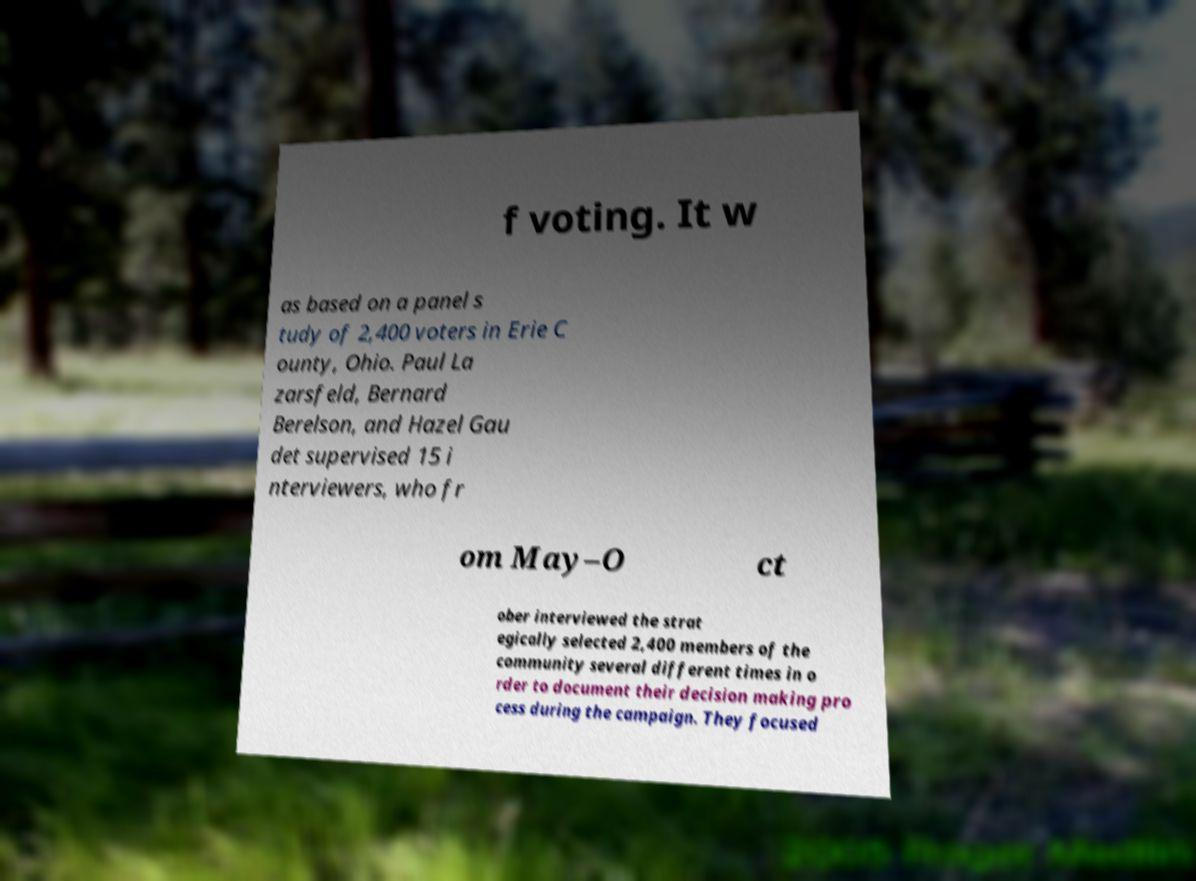There's text embedded in this image that I need extracted. Can you transcribe it verbatim? f voting. It w as based on a panel s tudy of 2,400 voters in Erie C ounty, Ohio. Paul La zarsfeld, Bernard Berelson, and Hazel Gau det supervised 15 i nterviewers, who fr om May–O ct ober interviewed the strat egically selected 2,400 members of the community several different times in o rder to document their decision making pro cess during the campaign. They focused 